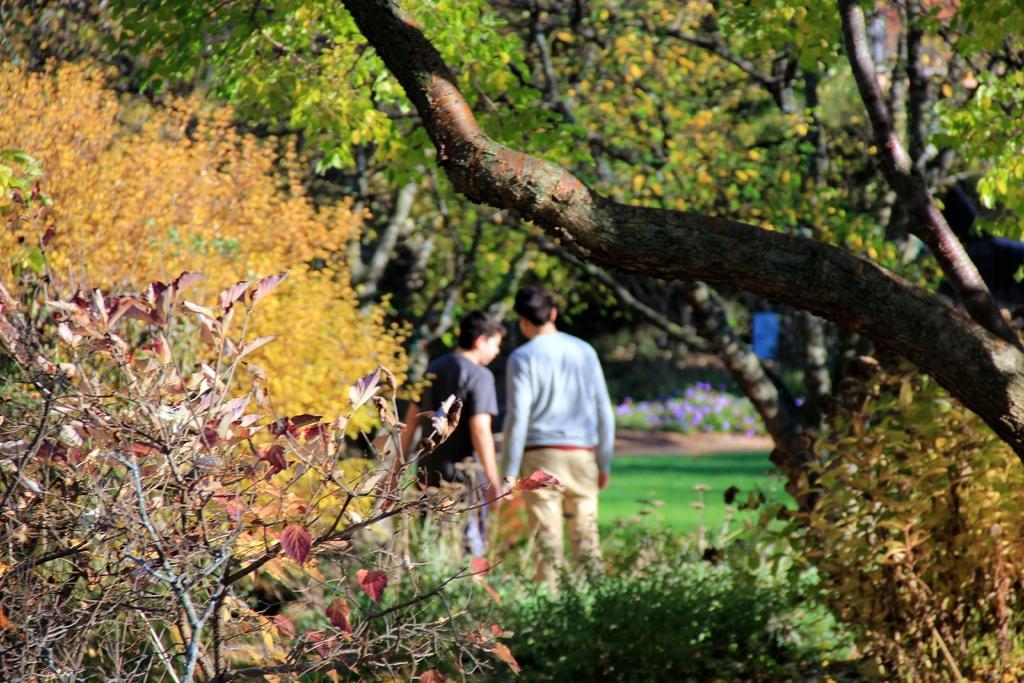Please provide a concise description of this image. In the picture we can see some plants and behind it, we can see two boys are standing holding each other hand and beside them, we can see some trees and in the background also we can see trees. 